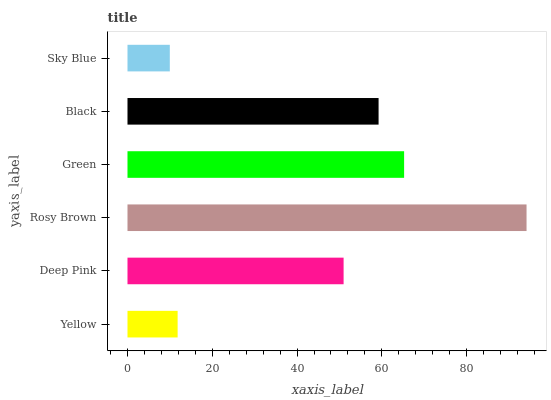Is Sky Blue the minimum?
Answer yes or no. Yes. Is Rosy Brown the maximum?
Answer yes or no. Yes. Is Deep Pink the minimum?
Answer yes or no. No. Is Deep Pink the maximum?
Answer yes or no. No. Is Deep Pink greater than Yellow?
Answer yes or no. Yes. Is Yellow less than Deep Pink?
Answer yes or no. Yes. Is Yellow greater than Deep Pink?
Answer yes or no. No. Is Deep Pink less than Yellow?
Answer yes or no. No. Is Black the high median?
Answer yes or no. Yes. Is Deep Pink the low median?
Answer yes or no. Yes. Is Green the high median?
Answer yes or no. No. Is Green the low median?
Answer yes or no. No. 